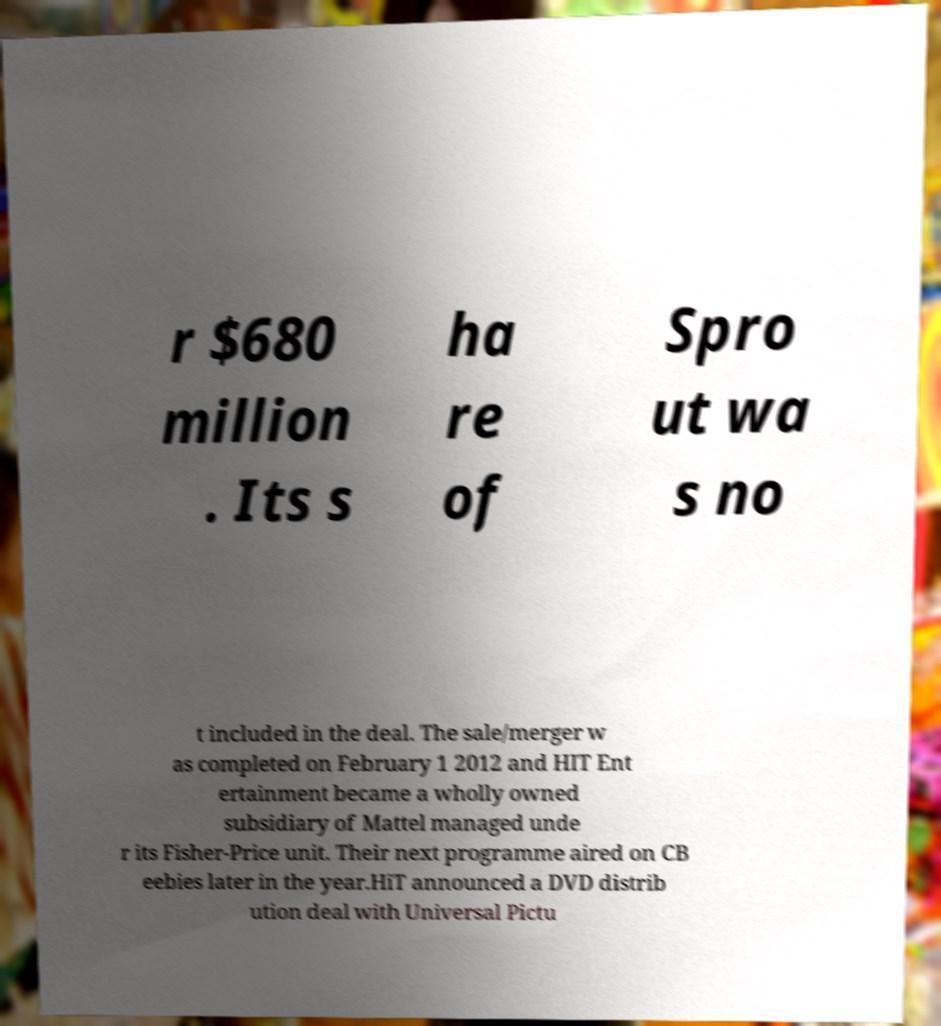Please identify and transcribe the text found in this image. r $680 million . Its s ha re of Spro ut wa s no t included in the deal. The sale/merger w as completed on February 1 2012 and HIT Ent ertainment became a wholly owned subsidiary of Mattel managed unde r its Fisher-Price unit. Their next programme aired on CB eebies later in the year.HiT announced a DVD distrib ution deal with Universal Pictu 